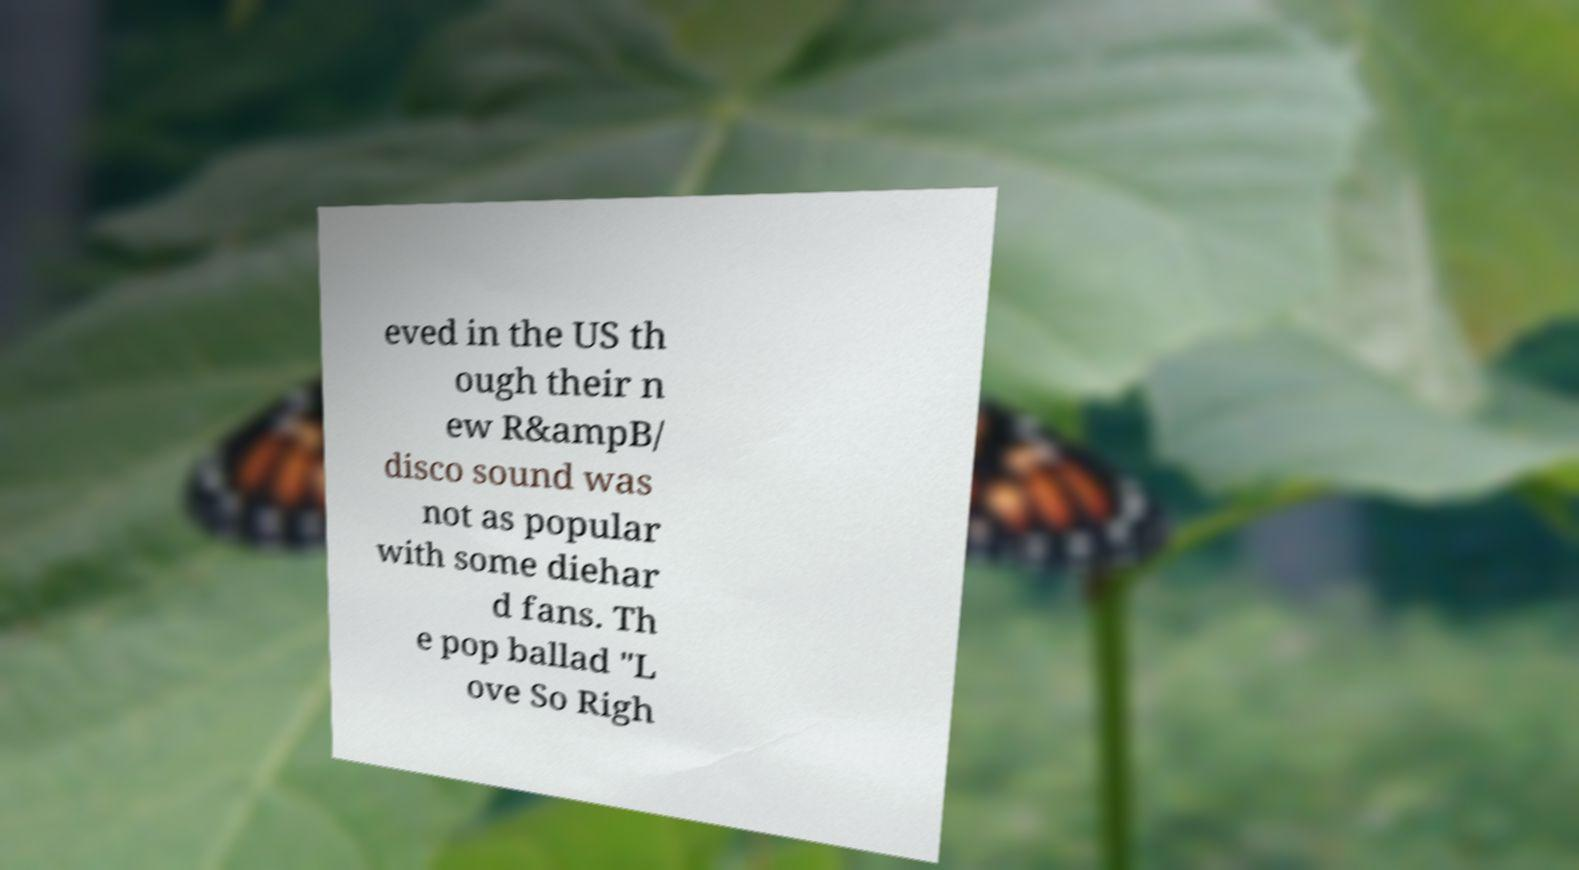Could you assist in decoding the text presented in this image and type it out clearly? eved in the US th ough their n ew R&ampB/ disco sound was not as popular with some diehar d fans. Th e pop ballad "L ove So Righ 